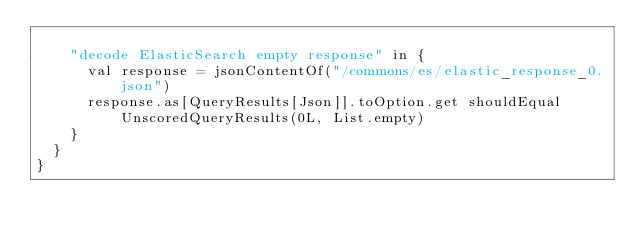<code> <loc_0><loc_0><loc_500><loc_500><_Scala_>
    "decode ElasticSearch empty response" in {
      val response = jsonContentOf("/commons/es/elastic_response_0.json")
      response.as[QueryResults[Json]].toOption.get shouldEqual UnscoredQueryResults(0L, List.empty)
    }
  }
}
</code> 